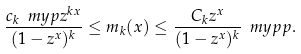<formula> <loc_0><loc_0><loc_500><loc_500>\frac { c _ { k } \ m y p z ^ { k x } } { ( 1 - z ^ { x } ) ^ { k } } \leq m _ { k } ( x ) \leq \frac { C _ { k } z ^ { x } } { ( 1 - z ^ { x } ) ^ { k } } \ m y p p .</formula> 